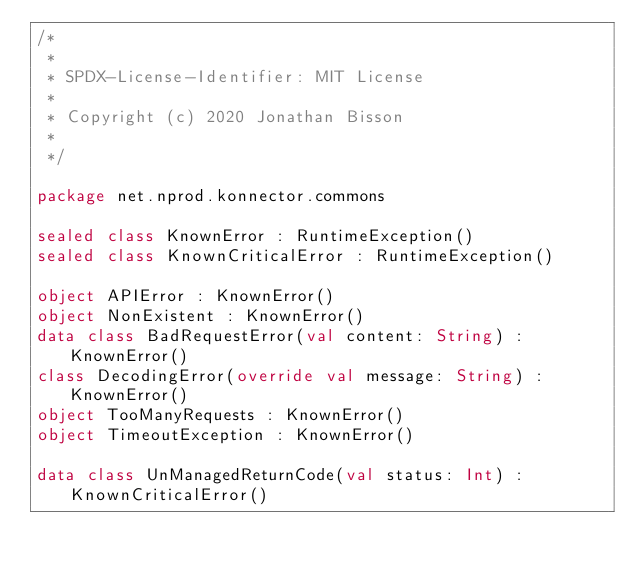<code> <loc_0><loc_0><loc_500><loc_500><_Kotlin_>/*
 *
 * SPDX-License-Identifier: MIT License
 *
 * Copyright (c) 2020 Jonathan Bisson
 *
 */

package net.nprod.konnector.commons

sealed class KnownError : RuntimeException()
sealed class KnownCriticalError : RuntimeException()

object APIError : KnownError()
object NonExistent : KnownError()
data class BadRequestError(val content: String) : KnownError()
class DecodingError(override val message: String) : KnownError()
object TooManyRequests : KnownError()
object TimeoutException : KnownError()

data class UnManagedReturnCode(val status: Int) : KnownCriticalError()
</code> 